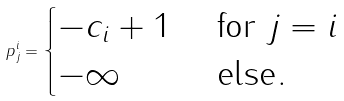<formula> <loc_0><loc_0><loc_500><loc_500>p ^ { i } _ { j } = \begin{cases} - c _ { i } + 1 & \text { for } j = i \\ - \infty & \text { else} . \end{cases}</formula> 